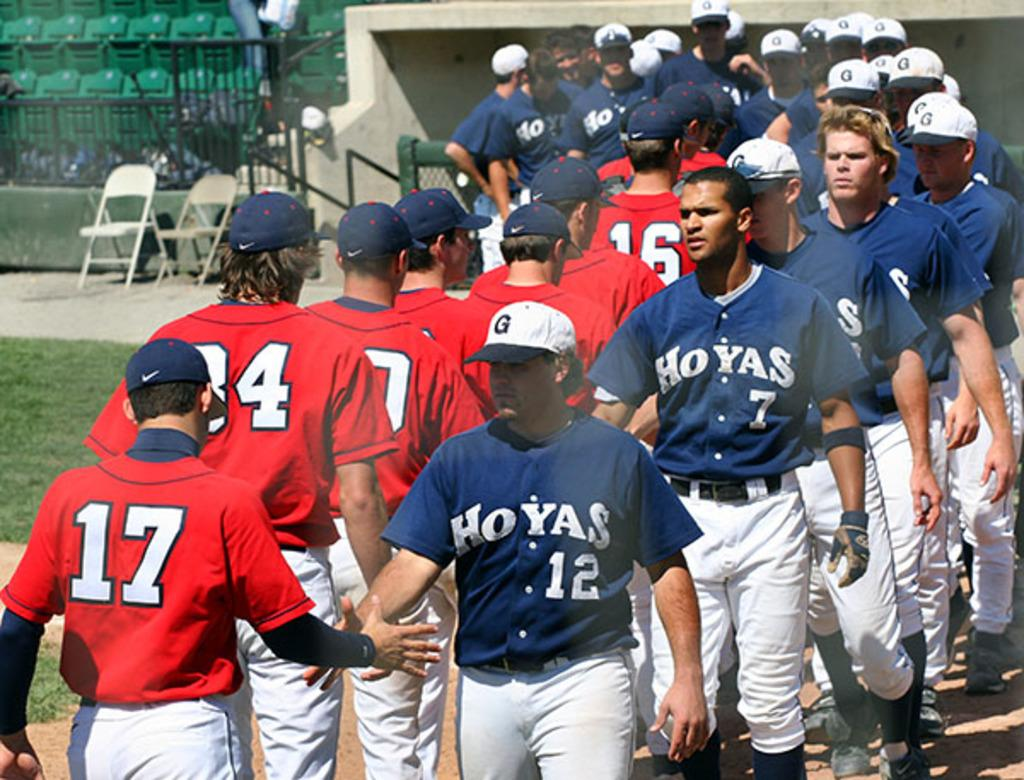<image>
Share a concise interpretation of the image provided. The Hoyas just finished a baseball game against another team. 